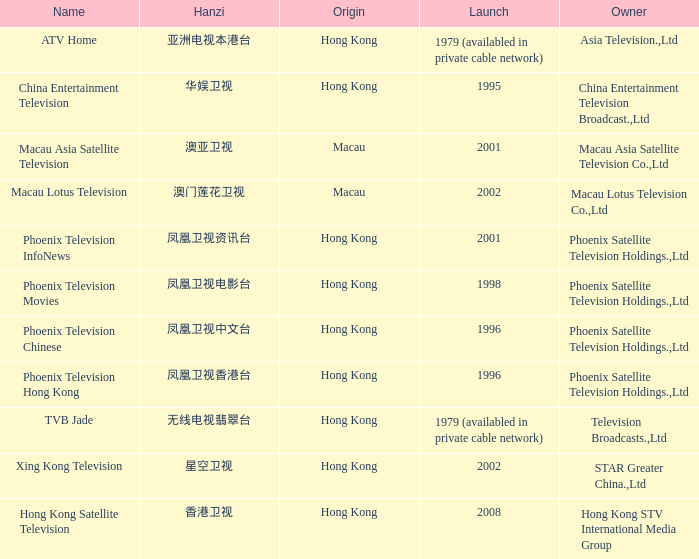Where did the Hanzi of 凤凰卫视电影台 originate? Hong Kong. 